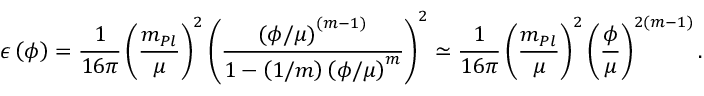<formula> <loc_0><loc_0><loc_500><loc_500>\epsilon \left ( \phi \right ) = { \frac { 1 } { 1 6 \pi } } \left ( \frac { m _ { P l } } { \mu } \right ) ^ { 2 } \left ( { \frac { \left ( \phi / \mu \right ) ^ { ( m - 1 ) } } { 1 - \left ( 1 / m \right ) \left ( \phi / \mu \right ) ^ { m } } } \right ) ^ { 2 } \simeq { \frac { 1 } { 1 6 \pi } } \left ( \frac { m _ { P l } } { \mu } \right ) ^ { 2 } \left ( \frac { \phi } { \mu } \right ) ^ { 2 ( m - 1 ) } .</formula> 